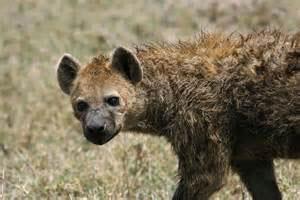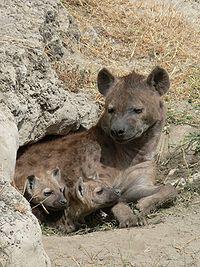The first image is the image on the left, the second image is the image on the right. Assess this claim about the two images: "The left image includes a fang-baring hyena with wide open mouth, and the right image contains exactly two hyenas in matching poses.". Correct or not? Answer yes or no. No. The first image is the image on the left, the second image is the image on the right. Analyze the images presented: Is the assertion "The left image contains at least two hyenas." valid? Answer yes or no. No. 